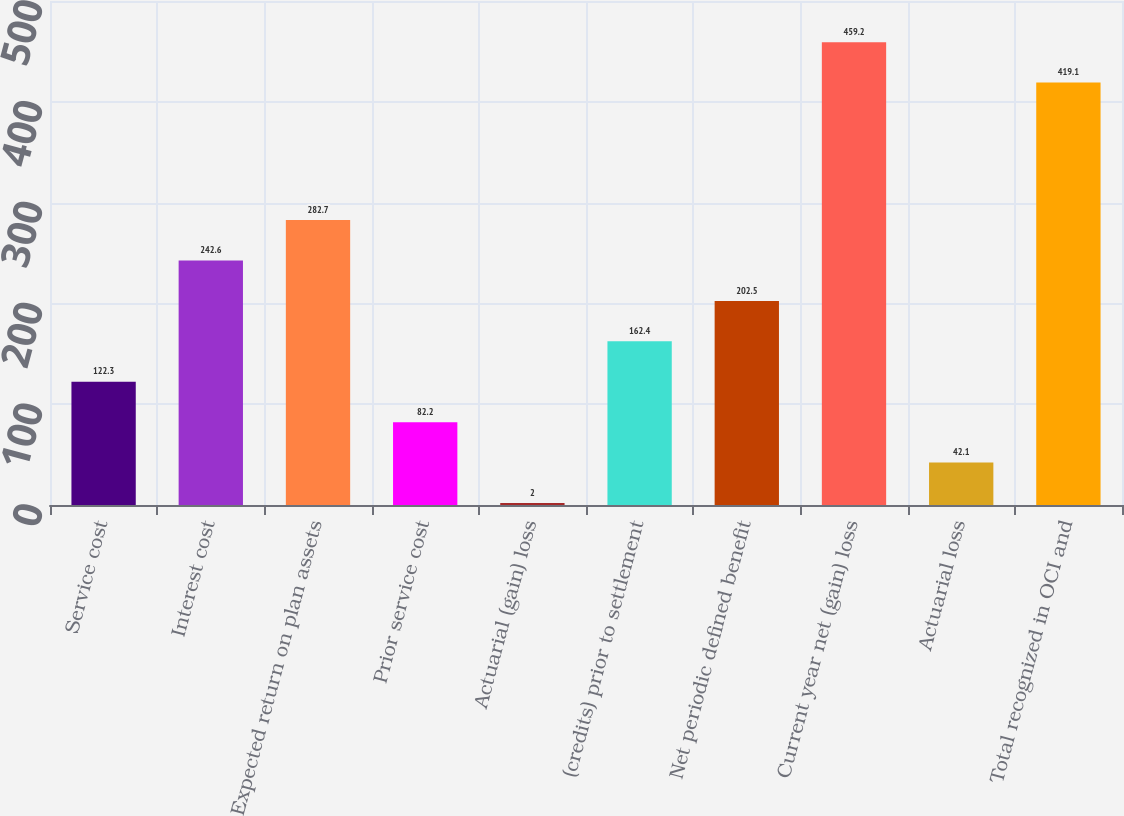<chart> <loc_0><loc_0><loc_500><loc_500><bar_chart><fcel>Service cost<fcel>Interest cost<fcel>Expected return on plan assets<fcel>Prior service cost<fcel>Actuarial (gain) loss<fcel>(credits) prior to settlement<fcel>Net periodic defined benefit<fcel>Current year net (gain) loss<fcel>Actuarial loss<fcel>Total recognized in OCI and<nl><fcel>122.3<fcel>242.6<fcel>282.7<fcel>82.2<fcel>2<fcel>162.4<fcel>202.5<fcel>459.2<fcel>42.1<fcel>419.1<nl></chart> 